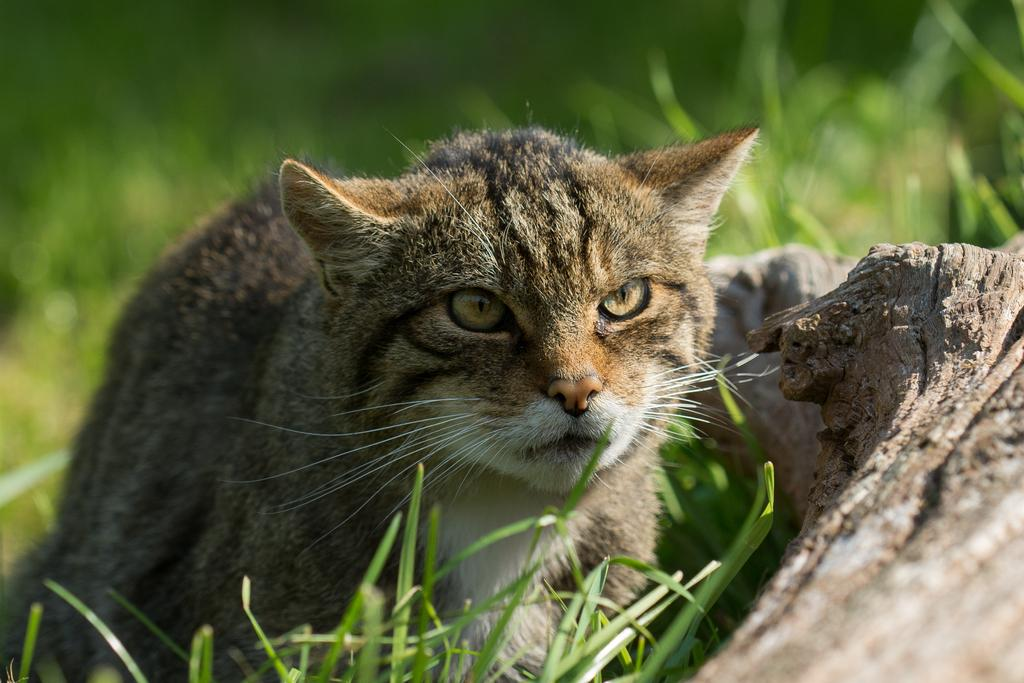What type of animal is in the image? There is a cat in the image. What other object can be seen in the image? There is a stone in the image. What type of vegetation is present in the image? There is grass in the image. What type of yak can be seen grazing on the grass in the image? There is no yak present in the image; it features a cat and a stone. How does the cat's digestion process work in the image? The image does not provide information about the cat's digestion process. 